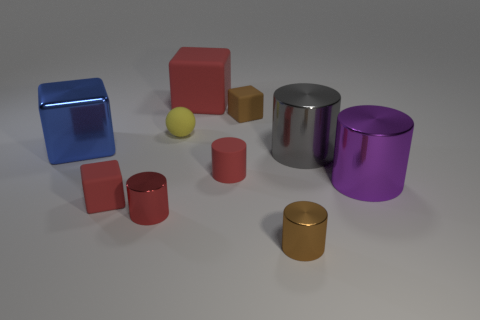What number of metallic objects have the same size as the brown rubber cube? There is one metallic object with the same size as the brown rubber cube, which is the small gold cylinder. 